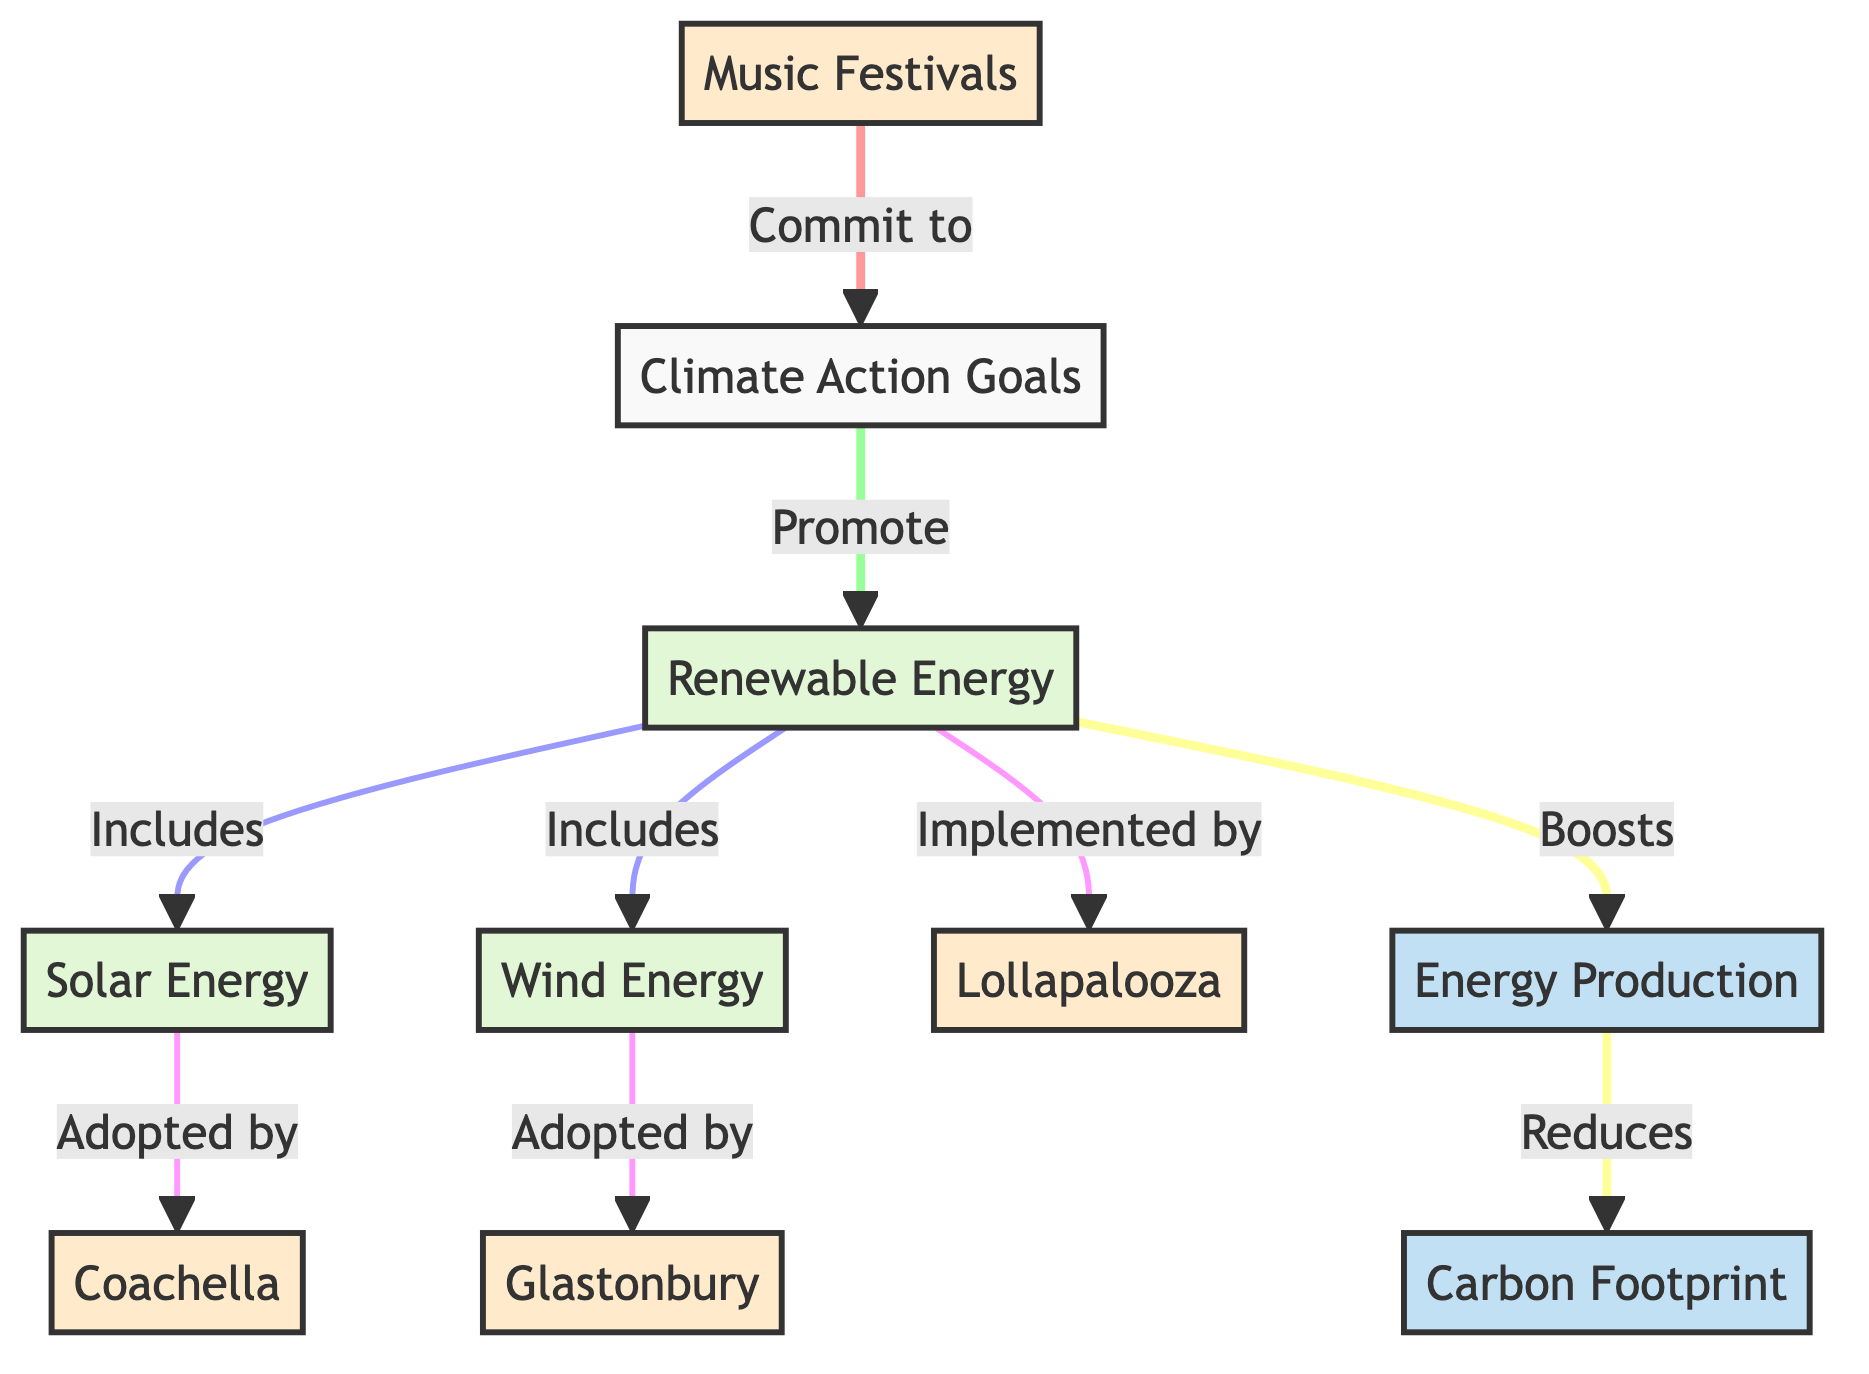What are the three components of renewable energy in this diagram? The renewable energy components listed in the diagram are solar energy, wind energy, and renewable energy itself. By counting the distinct segments that represent renewable energy, we identify three components.
Answer: solar energy, wind energy, renewable energy Which music festival is specifically associated with solar energy? In the flowchart, the arrow from solar energy points directly to Coachella, indicating that this festival is the one specifically adopting solar energy.
Answer: Coachella How many music festivals are mentioned in the diagram? The diagram lists three distinct music festivals: Coachella, Glastonbury, and Lollapalooza. By counting the festivals in the flowchart, we arrive at the total of three.
Answer: 3 What effect does the implementation of renewable energy have on carbon footprint? The diagram indicates that implementing renewable energy boosts energy production, which in turn reduces carbon footprint. This shows a clear relationship where renewable energy contributes to lowering carbon emissions.
Answer: reduces Which festival is associated with wind energy? The connection in the diagram shows that wind energy is adopted by Glastonbury, thereby linking this festival specifically to the use of wind energy.
Answer: Glastonbury What does renewable energy boost according to the diagram? The flowchart states that renewable energy boosts energy production. By following the connections, we see that this is a direct consequence of the implementation of renewable energy sources.
Answer: energy production How does the diagram illustrate the commitment of music festivals to climate action goals? The diagram outlines that music festivals commit to climate action goals, which then promotes renewable energy. This step-by-step flow displays how festivals are actively moving towards enhancing their sustainability efforts.
Answer: promote renewable energy What is the relationship between renewable energy and carbon footprint in the flowchart? The flowchart shows a flow of information where renewable energy boosts energy production, which ultimately leads to a reduction in carbon footprint. Thus, renewable energy plays an integral role in decreasing carbon emissions.
Answer: reduces CF 